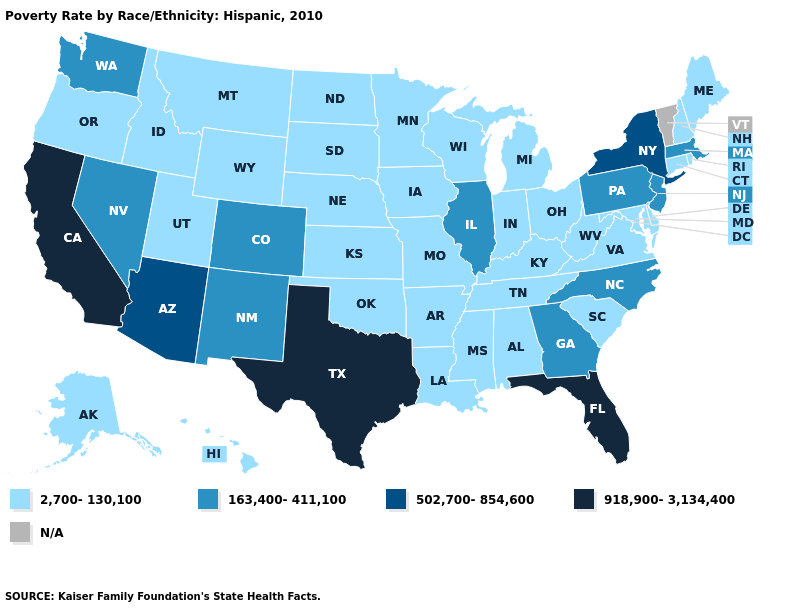Name the states that have a value in the range 2,700-130,100?
Concise answer only. Alabama, Alaska, Arkansas, Connecticut, Delaware, Hawaii, Idaho, Indiana, Iowa, Kansas, Kentucky, Louisiana, Maine, Maryland, Michigan, Minnesota, Mississippi, Missouri, Montana, Nebraska, New Hampshire, North Dakota, Ohio, Oklahoma, Oregon, Rhode Island, South Carolina, South Dakota, Tennessee, Utah, Virginia, West Virginia, Wisconsin, Wyoming. Name the states that have a value in the range N/A?
Concise answer only. Vermont. Name the states that have a value in the range 918,900-3,134,400?
Give a very brief answer. California, Florida, Texas. What is the value of Florida?
Write a very short answer. 918,900-3,134,400. What is the highest value in the MidWest ?
Be succinct. 163,400-411,100. Does Wisconsin have the highest value in the MidWest?
Quick response, please. No. Which states hav the highest value in the South?
Be succinct. Florida, Texas. What is the value of Tennessee?
Be succinct. 2,700-130,100. What is the value of Massachusetts?
Write a very short answer. 163,400-411,100. Is the legend a continuous bar?
Give a very brief answer. No. What is the highest value in states that border Delaware?
Quick response, please. 163,400-411,100. What is the highest value in the USA?
Quick response, please. 918,900-3,134,400. What is the value of Pennsylvania?
Concise answer only. 163,400-411,100. Name the states that have a value in the range 163,400-411,100?
Answer briefly. Colorado, Georgia, Illinois, Massachusetts, Nevada, New Jersey, New Mexico, North Carolina, Pennsylvania, Washington. 